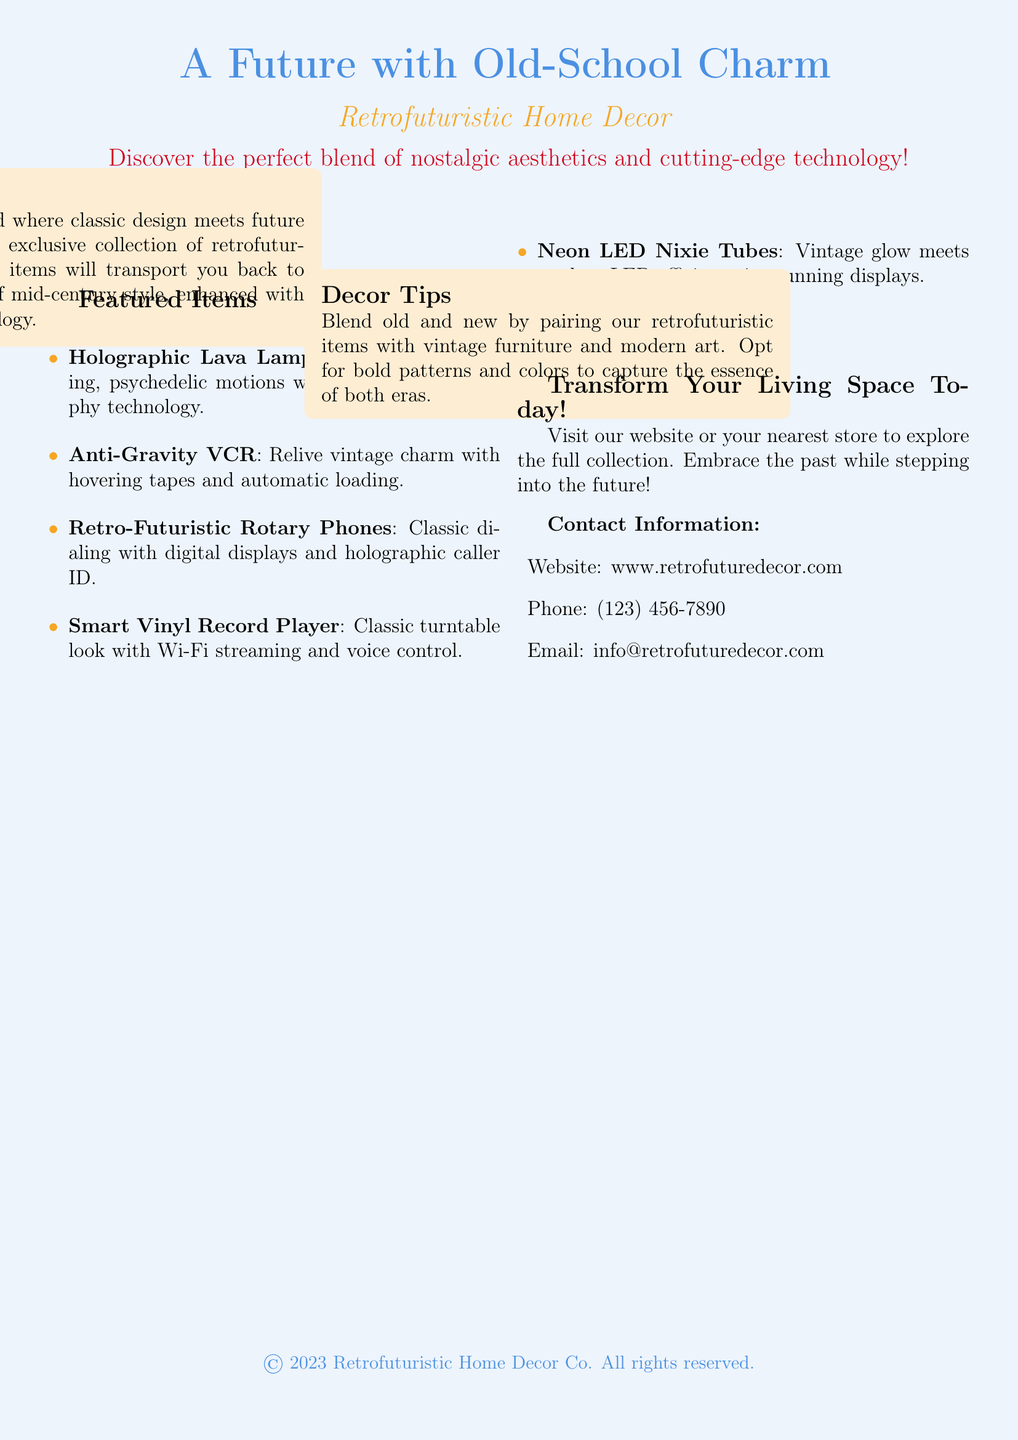What is the title of the flyer? The title of the flyer is the main heading and reflects the theme of the collection, which is prominently displayed at the top.
Answer: A Future with Old-School Charm What are holographic lava lamps? Holographic lava lamps are highlighted in the flyer as one of the featured items, showcasing advanced holography technology for soothing motions.
Answer: Experience soothing, psychedelic motions with advanced holography technology How many featured items are listed? The flyer provides a specific list of items, which can be counted to determine the total number of featured items.
Answer: Five What decor tips are offered? The flyer includes a section on decor tips that suggests how to effectively blend retrofuturistic items with existing decor styles.
Answer: Blend old and new by pairing our retrofuturistic items with vintage furniture and modern art What type of phone is featured in the collection? The featured item section describes a specific type of phone that combines classic and modern elements.
Answer: Retro-Futuristic Rotary Phones What is the website to explore the collection? The document provides contact information, including a website address for customers to explore the full collection.
Answer: www.retrofuturedecor.com What color theme does the flyer predominantly use? The flyer utilizes a specific color scheme that is consistent throughout the design and text elements.
Answer: Retro blue What concept is emphasized in the flyer? The flyer promotes a unique collection that merges different styles, highlighting a specific design philosophy or aesthetic.
Answer: Nostalgic aesthetics and cutting-edge technology 